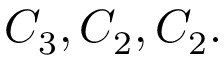Convert formula to latex. <formula><loc_0><loc_0><loc_500><loc_500>C _ { 3 } , C _ { 2 } , C _ { 2 } .</formula> 